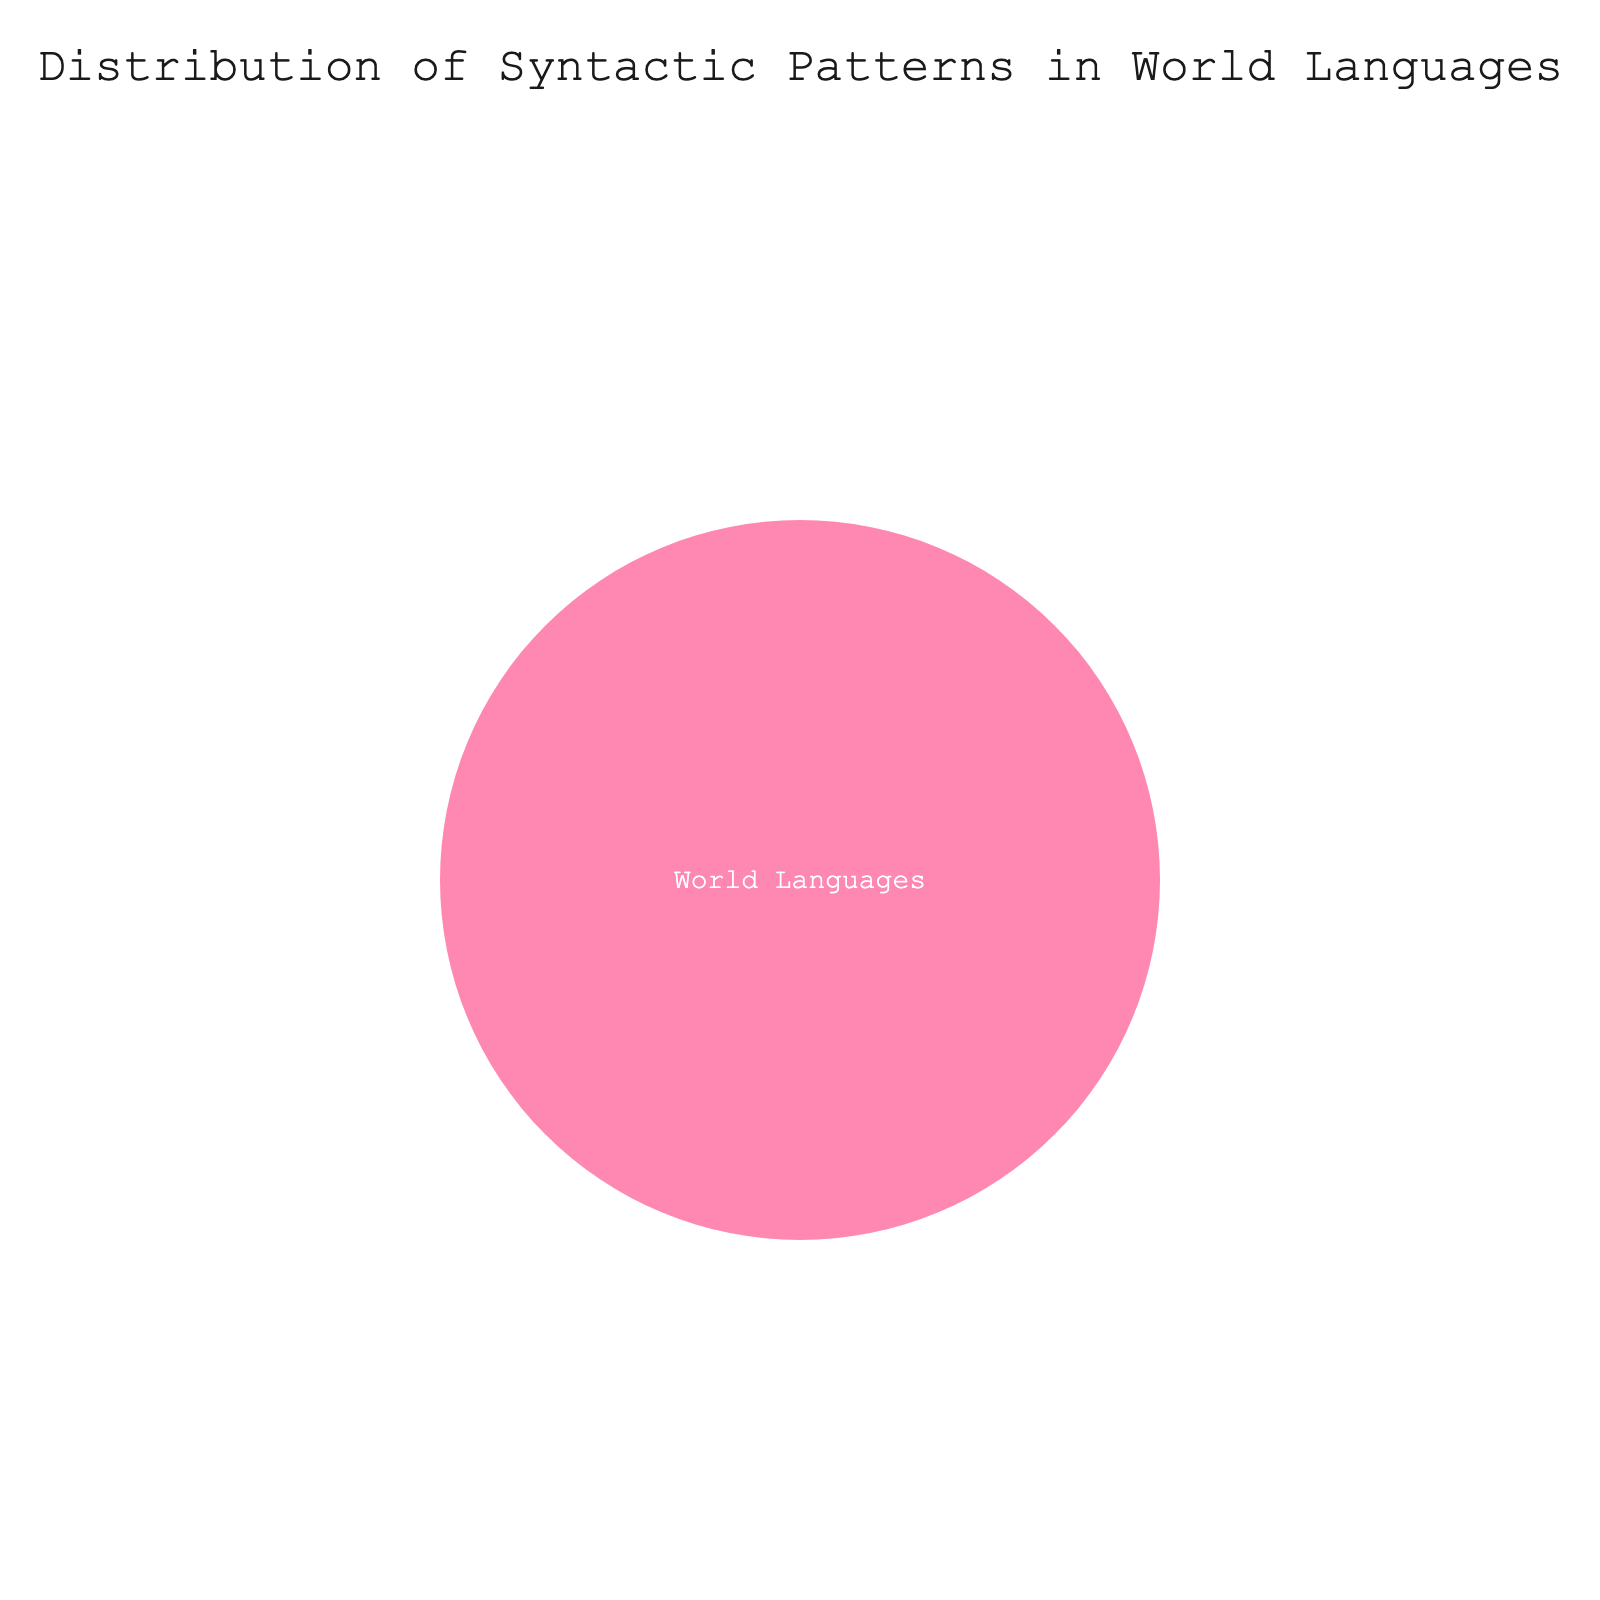What is the title of the figure? The title is usually the text displayed at the top of the figure. In this case, identify the phrase displayed in the title section of the plot.
Answer: Distribution of Syntactic Patterns in World Languages What are the main categories represented in the plot? Look at the outermost segments of the sunburst plot. They represent the highest level of categories.
Answer: Africa, Europe, Asia, North America, South America, Oceania What does each color in the sunburst plot represent? In sunburst plots, colors are often mapped to different categories or subcategories. Identify which feature the different colors signify.
Answer: Each color represents a different continent Which subcategory represents Africa? In the plot, the subcategories are labeled by name. Identify the subcategory label "Africa".
Answer: Africa Among the continents listed, are there any that do not display any syntax pattern data? Examine the values associated with each continent to see if any are zero.
Answer: All continents have a value of 0 What percentage of the total value does each continent represent? Since all continents have a value of 0, the percentage is obtained by calculating 0/0 for each continent.
Answer: 0% How is the value information visually encoded in the plot? Look at how the values are represented, whether through the size of segments, colors, or text annotations.
Answer: Values are encoded by the size of the segments Can we determine the absolute values of syntactic patterns for each continent from this figure? Examine the data provided in the hover information or represented in the segments to see if absolute values are shown.
Answer: No, all values are 0 What is the visual impact of filling missing values with 0? Consider how filling missing values with zero affects the visual representation. Since all values are zero, it would affect the plot's readability and interpretation.
Answer: It results in all segments having equal size, making it difficult to interpret differentiation Is it possible to determine which continent has the most diverse set of syntactic patterns based on the plot? Based on the sunburst plot showing all continents with equal values, analyze the ability to distinguish diversity in syntactic patterns.
Answer: No, all values are 0, so diversity cannot be assessed 